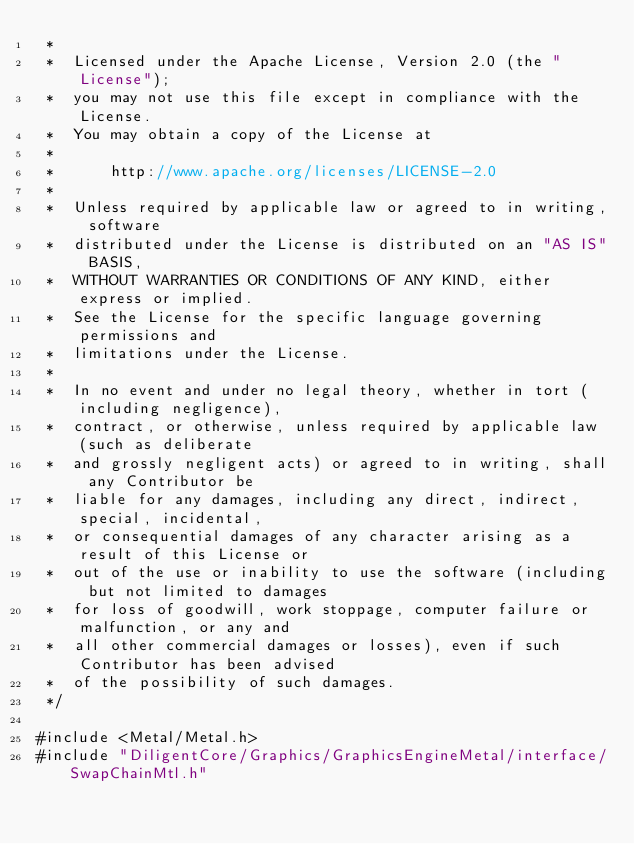Convert code to text. <code><loc_0><loc_0><loc_500><loc_500><_ObjectiveC_> *  
 *  Licensed under the Apache License, Version 2.0 (the "License");
 *  you may not use this file except in compliance with the License.
 *  You may obtain a copy of the License at
 *  
 *      http://www.apache.org/licenses/LICENSE-2.0
 *  
 *  Unless required by applicable law or agreed to in writing, software
 *  distributed under the License is distributed on an "AS IS" BASIS,
 *  WITHOUT WARRANTIES OR CONDITIONS OF ANY KIND, either express or implied.
 *  See the License for the specific language governing permissions and
 *  limitations under the License.
 *
 *  In no event and under no legal theory, whether in tort (including negligence), 
 *  contract, or otherwise, unless required by applicable law (such as deliberate 
 *  and grossly negligent acts) or agreed to in writing, shall any Contributor be
 *  liable for any damages, including any direct, indirect, special, incidental, 
 *  or consequential damages of any character arising as a result of this License or 
 *  out of the use or inability to use the software (including but not limited to damages 
 *  for loss of goodwill, work stoppage, computer failure or malfunction, or any and 
 *  all other commercial damages or losses), even if such Contributor has been advised 
 *  of the possibility of such damages.
 */

#include <Metal/Metal.h>
#include "DiligentCore/Graphics/GraphicsEngineMetal/interface/SwapChainMtl.h"
</code> 